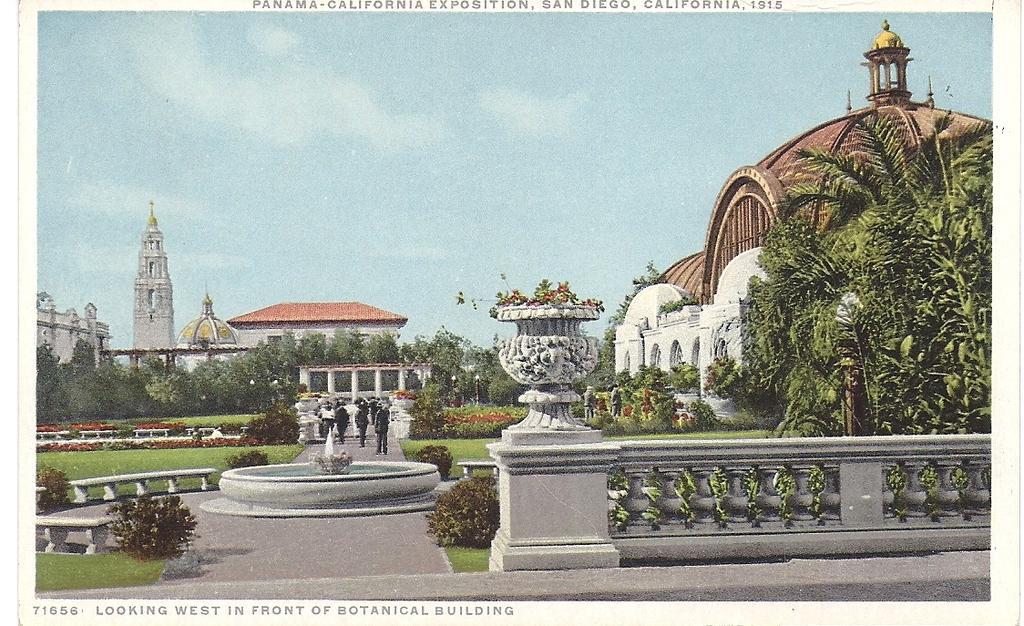In one or two sentences, can you explain what this image depicts? In this image there is the sky, there are buildings, there is a building truncated towards the left of the image, there is a building truncated towards the right of the image, there are trees, there are trees truncated towards the left of the image, there are truncated towards the right of the image, there are plants, there is grass, there is a bench, there is a fountain, there are group of persons walking. 